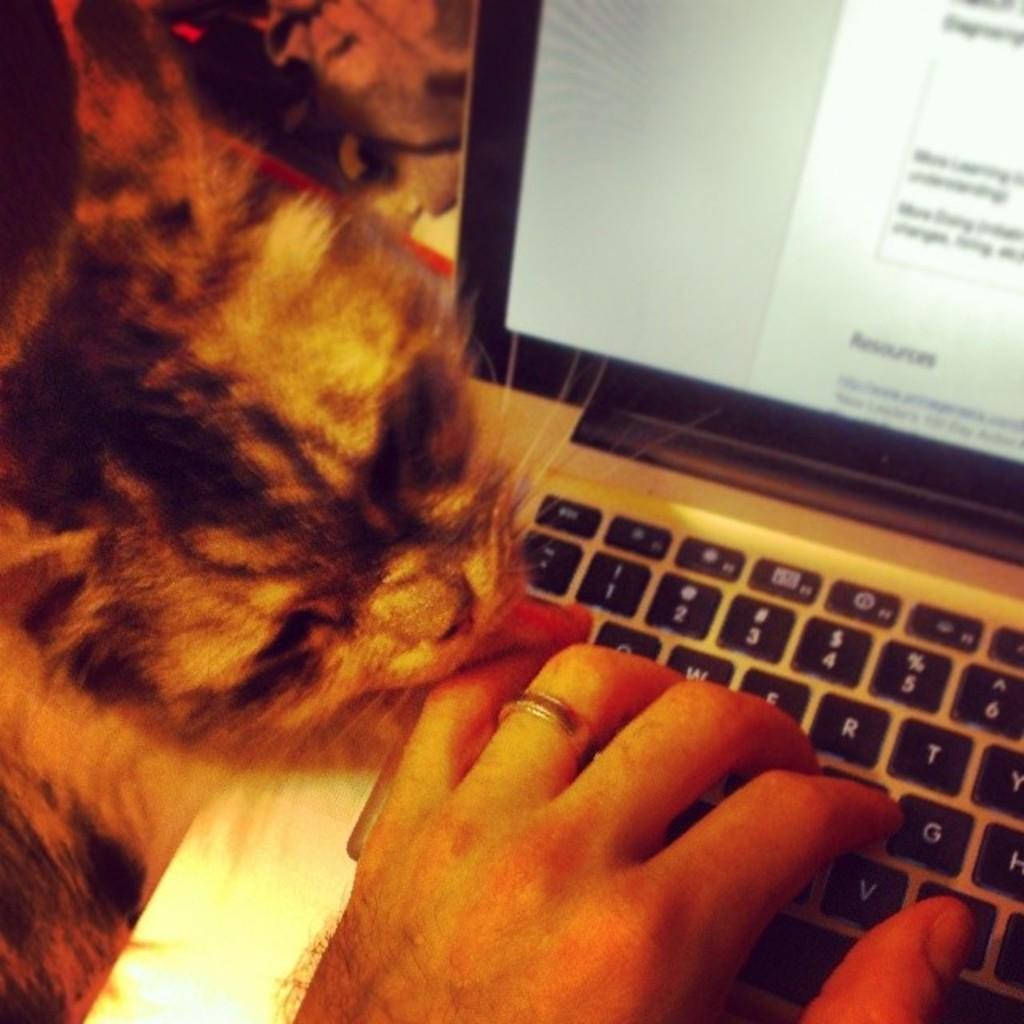Can you describe this image briefly? In this image we can see a human hand on the laptop. There is a cat on the left side of the image. 